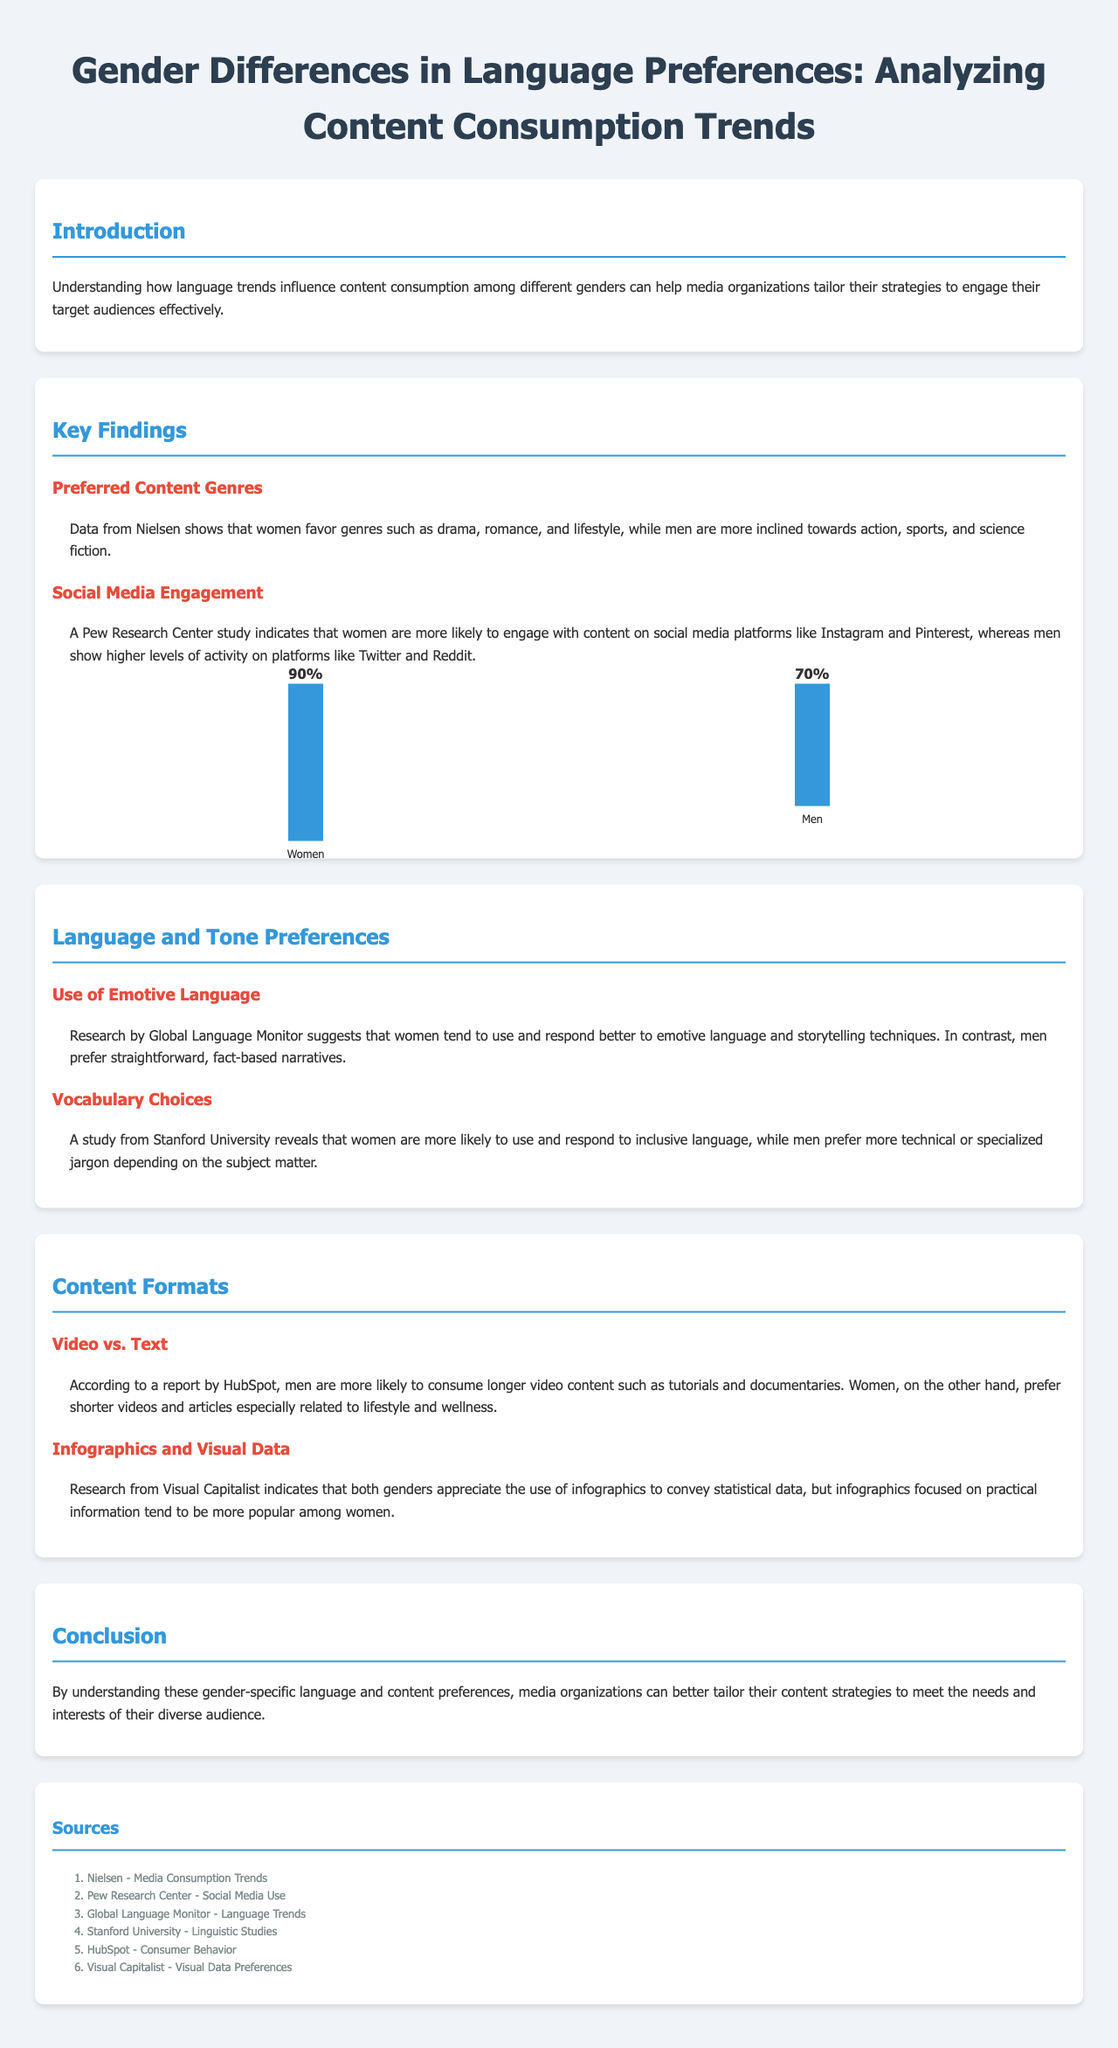What genres do women prefer? Women favor genres such as drama, romance, and lifestyle according to the data provided.
Answer: Drama, romance, lifestyle What genres do men prefer? Men are more inclined towards action, sports, and science fiction according to the findings.
Answer: Action, sports, science fiction What percentage of women engage with content on social media? The document states that 90% of women engage with content on social media platforms.
Answer: 90% What percentage of men engage with content on social media? According to the chart, 70% of men engage with content on social media platforms.
Answer: 70% What type of language do women tend to use? The research suggests that women tend to use emotive language and storytelling techniques.
Answer: Emotive language What type of language do men prefer? Men prefer straightforward, fact-based narratives according to the findings in the document.
Answer: Fact-based narratives Which content format do men prefer for longer consumption? Men are more likely to consume longer video content such as tutorials and documentaries.
Answer: Longer video content What type of infographics are more popular among women? Infographics focused on practical information tend to be more popular among women according to the research.
Answer: Practical information What is the main conclusion of the document? The conclusion emphasizes tailoring content strategies to meet the needs and interests of diverse audiences based on gender preferences.
Answer: Tailor content strategies 